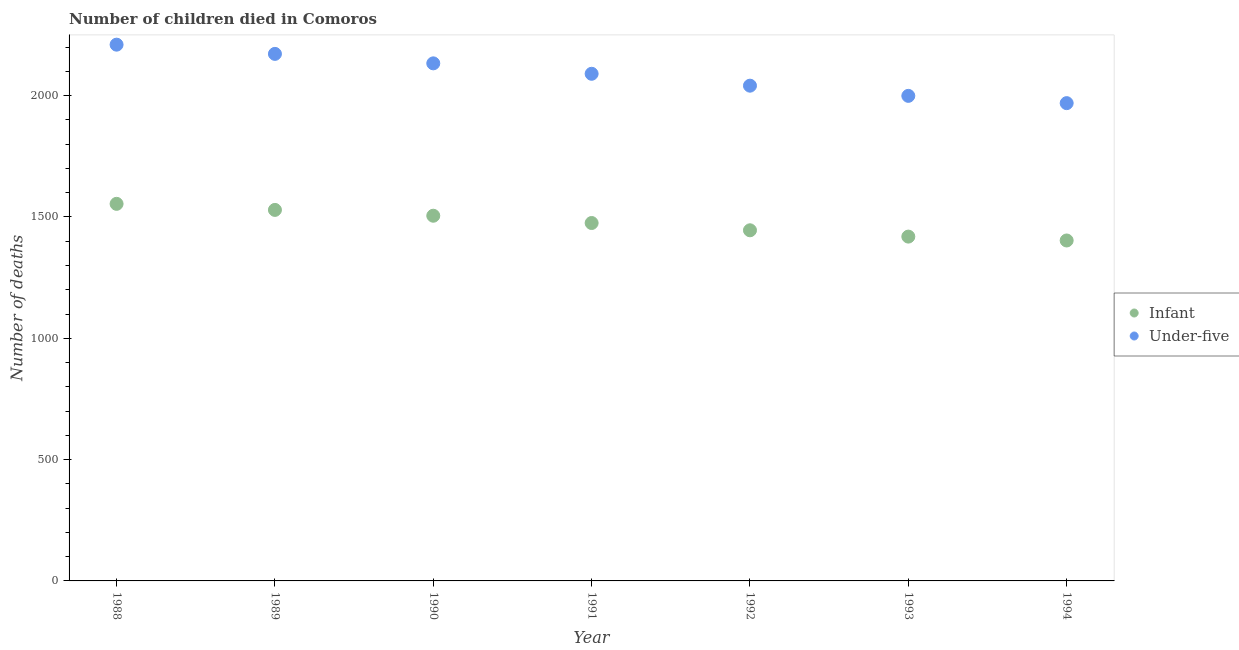Is the number of dotlines equal to the number of legend labels?
Your answer should be compact. Yes. What is the number of under-five deaths in 1994?
Give a very brief answer. 1969. Across all years, what is the maximum number of under-five deaths?
Offer a terse response. 2210. Across all years, what is the minimum number of under-five deaths?
Provide a succinct answer. 1969. In which year was the number of under-five deaths maximum?
Provide a succinct answer. 1988. In which year was the number of under-five deaths minimum?
Make the answer very short. 1994. What is the total number of under-five deaths in the graph?
Your answer should be compact. 1.46e+04. What is the difference between the number of infant deaths in 1988 and that in 1994?
Provide a short and direct response. 151. What is the difference between the number of under-five deaths in 1990 and the number of infant deaths in 1992?
Ensure brevity in your answer.  688. What is the average number of infant deaths per year?
Your response must be concise. 1475.71. In the year 1991, what is the difference between the number of under-five deaths and number of infant deaths?
Your response must be concise. 615. What is the ratio of the number of under-five deaths in 1989 to that in 1990?
Provide a succinct answer. 1.02. What is the difference between the highest and the second highest number of infant deaths?
Ensure brevity in your answer.  25. What is the difference between the highest and the lowest number of infant deaths?
Your answer should be very brief. 151. Is the sum of the number of under-five deaths in 1989 and 1994 greater than the maximum number of infant deaths across all years?
Keep it short and to the point. Yes. Is the number of infant deaths strictly greater than the number of under-five deaths over the years?
Offer a terse response. No. How many dotlines are there?
Ensure brevity in your answer.  2. Does the graph contain grids?
Offer a very short reply. No. How many legend labels are there?
Provide a short and direct response. 2. What is the title of the graph?
Provide a succinct answer. Number of children died in Comoros. Does "Depositors" appear as one of the legend labels in the graph?
Your answer should be very brief. No. What is the label or title of the X-axis?
Ensure brevity in your answer.  Year. What is the label or title of the Y-axis?
Make the answer very short. Number of deaths. What is the Number of deaths in Infant in 1988?
Provide a short and direct response. 1554. What is the Number of deaths in Under-five in 1988?
Provide a succinct answer. 2210. What is the Number of deaths in Infant in 1989?
Keep it short and to the point. 1529. What is the Number of deaths of Under-five in 1989?
Provide a succinct answer. 2172. What is the Number of deaths in Infant in 1990?
Your answer should be compact. 1505. What is the Number of deaths of Under-five in 1990?
Provide a succinct answer. 2133. What is the Number of deaths of Infant in 1991?
Your answer should be compact. 1475. What is the Number of deaths of Under-five in 1991?
Make the answer very short. 2090. What is the Number of deaths in Infant in 1992?
Keep it short and to the point. 1445. What is the Number of deaths in Under-five in 1992?
Give a very brief answer. 2041. What is the Number of deaths in Infant in 1993?
Keep it short and to the point. 1419. What is the Number of deaths of Under-five in 1993?
Your answer should be compact. 1999. What is the Number of deaths in Infant in 1994?
Provide a short and direct response. 1403. What is the Number of deaths of Under-five in 1994?
Your response must be concise. 1969. Across all years, what is the maximum Number of deaths of Infant?
Make the answer very short. 1554. Across all years, what is the maximum Number of deaths in Under-five?
Your response must be concise. 2210. Across all years, what is the minimum Number of deaths of Infant?
Offer a very short reply. 1403. Across all years, what is the minimum Number of deaths of Under-five?
Offer a terse response. 1969. What is the total Number of deaths of Infant in the graph?
Give a very brief answer. 1.03e+04. What is the total Number of deaths of Under-five in the graph?
Your response must be concise. 1.46e+04. What is the difference between the Number of deaths of Infant in 1988 and that in 1989?
Keep it short and to the point. 25. What is the difference between the Number of deaths in Infant in 1988 and that in 1990?
Ensure brevity in your answer.  49. What is the difference between the Number of deaths of Infant in 1988 and that in 1991?
Make the answer very short. 79. What is the difference between the Number of deaths of Under-five in 1988 and that in 1991?
Your response must be concise. 120. What is the difference between the Number of deaths of Infant in 1988 and that in 1992?
Offer a terse response. 109. What is the difference between the Number of deaths in Under-five in 1988 and that in 1992?
Offer a very short reply. 169. What is the difference between the Number of deaths of Infant in 1988 and that in 1993?
Make the answer very short. 135. What is the difference between the Number of deaths in Under-five in 1988 and that in 1993?
Your answer should be compact. 211. What is the difference between the Number of deaths of Infant in 1988 and that in 1994?
Make the answer very short. 151. What is the difference between the Number of deaths in Under-five in 1988 and that in 1994?
Give a very brief answer. 241. What is the difference between the Number of deaths in Under-five in 1989 and that in 1991?
Give a very brief answer. 82. What is the difference between the Number of deaths of Infant in 1989 and that in 1992?
Make the answer very short. 84. What is the difference between the Number of deaths of Under-five in 1989 and that in 1992?
Provide a succinct answer. 131. What is the difference between the Number of deaths of Infant in 1989 and that in 1993?
Your response must be concise. 110. What is the difference between the Number of deaths of Under-five in 1989 and that in 1993?
Your answer should be very brief. 173. What is the difference between the Number of deaths of Infant in 1989 and that in 1994?
Offer a very short reply. 126. What is the difference between the Number of deaths in Under-five in 1989 and that in 1994?
Offer a terse response. 203. What is the difference between the Number of deaths in Infant in 1990 and that in 1991?
Offer a very short reply. 30. What is the difference between the Number of deaths in Infant in 1990 and that in 1992?
Offer a very short reply. 60. What is the difference between the Number of deaths of Under-five in 1990 and that in 1992?
Ensure brevity in your answer.  92. What is the difference between the Number of deaths in Under-five in 1990 and that in 1993?
Your answer should be compact. 134. What is the difference between the Number of deaths of Infant in 1990 and that in 1994?
Make the answer very short. 102. What is the difference between the Number of deaths of Under-five in 1990 and that in 1994?
Make the answer very short. 164. What is the difference between the Number of deaths of Infant in 1991 and that in 1992?
Your response must be concise. 30. What is the difference between the Number of deaths in Under-five in 1991 and that in 1993?
Offer a terse response. 91. What is the difference between the Number of deaths in Infant in 1991 and that in 1994?
Keep it short and to the point. 72. What is the difference between the Number of deaths of Under-five in 1991 and that in 1994?
Make the answer very short. 121. What is the difference between the Number of deaths in Infant in 1992 and that in 1993?
Offer a very short reply. 26. What is the difference between the Number of deaths of Infant in 1992 and that in 1994?
Your answer should be compact. 42. What is the difference between the Number of deaths of Under-five in 1992 and that in 1994?
Your answer should be very brief. 72. What is the difference between the Number of deaths of Under-five in 1993 and that in 1994?
Your answer should be very brief. 30. What is the difference between the Number of deaths of Infant in 1988 and the Number of deaths of Under-five in 1989?
Give a very brief answer. -618. What is the difference between the Number of deaths of Infant in 1988 and the Number of deaths of Under-five in 1990?
Provide a short and direct response. -579. What is the difference between the Number of deaths of Infant in 1988 and the Number of deaths of Under-five in 1991?
Your answer should be compact. -536. What is the difference between the Number of deaths of Infant in 1988 and the Number of deaths of Under-five in 1992?
Provide a succinct answer. -487. What is the difference between the Number of deaths in Infant in 1988 and the Number of deaths in Under-five in 1993?
Give a very brief answer. -445. What is the difference between the Number of deaths in Infant in 1988 and the Number of deaths in Under-five in 1994?
Provide a short and direct response. -415. What is the difference between the Number of deaths in Infant in 1989 and the Number of deaths in Under-five in 1990?
Keep it short and to the point. -604. What is the difference between the Number of deaths in Infant in 1989 and the Number of deaths in Under-five in 1991?
Keep it short and to the point. -561. What is the difference between the Number of deaths in Infant in 1989 and the Number of deaths in Under-five in 1992?
Give a very brief answer. -512. What is the difference between the Number of deaths of Infant in 1989 and the Number of deaths of Under-five in 1993?
Your answer should be compact. -470. What is the difference between the Number of deaths in Infant in 1989 and the Number of deaths in Under-five in 1994?
Your response must be concise. -440. What is the difference between the Number of deaths in Infant in 1990 and the Number of deaths in Under-five in 1991?
Give a very brief answer. -585. What is the difference between the Number of deaths of Infant in 1990 and the Number of deaths of Under-five in 1992?
Your response must be concise. -536. What is the difference between the Number of deaths in Infant in 1990 and the Number of deaths in Under-five in 1993?
Your response must be concise. -494. What is the difference between the Number of deaths in Infant in 1990 and the Number of deaths in Under-five in 1994?
Give a very brief answer. -464. What is the difference between the Number of deaths of Infant in 1991 and the Number of deaths of Under-five in 1992?
Provide a short and direct response. -566. What is the difference between the Number of deaths in Infant in 1991 and the Number of deaths in Under-five in 1993?
Ensure brevity in your answer.  -524. What is the difference between the Number of deaths of Infant in 1991 and the Number of deaths of Under-five in 1994?
Your answer should be compact. -494. What is the difference between the Number of deaths in Infant in 1992 and the Number of deaths in Under-five in 1993?
Your response must be concise. -554. What is the difference between the Number of deaths in Infant in 1992 and the Number of deaths in Under-five in 1994?
Your response must be concise. -524. What is the difference between the Number of deaths in Infant in 1993 and the Number of deaths in Under-five in 1994?
Give a very brief answer. -550. What is the average Number of deaths of Infant per year?
Your response must be concise. 1475.71. What is the average Number of deaths of Under-five per year?
Offer a very short reply. 2087.71. In the year 1988, what is the difference between the Number of deaths of Infant and Number of deaths of Under-five?
Your response must be concise. -656. In the year 1989, what is the difference between the Number of deaths in Infant and Number of deaths in Under-five?
Give a very brief answer. -643. In the year 1990, what is the difference between the Number of deaths in Infant and Number of deaths in Under-five?
Your answer should be compact. -628. In the year 1991, what is the difference between the Number of deaths in Infant and Number of deaths in Under-five?
Provide a short and direct response. -615. In the year 1992, what is the difference between the Number of deaths of Infant and Number of deaths of Under-five?
Give a very brief answer. -596. In the year 1993, what is the difference between the Number of deaths in Infant and Number of deaths in Under-five?
Make the answer very short. -580. In the year 1994, what is the difference between the Number of deaths of Infant and Number of deaths of Under-five?
Make the answer very short. -566. What is the ratio of the Number of deaths of Infant in 1988 to that in 1989?
Offer a very short reply. 1.02. What is the ratio of the Number of deaths of Under-five in 1988 to that in 1989?
Ensure brevity in your answer.  1.02. What is the ratio of the Number of deaths of Infant in 1988 to that in 1990?
Provide a short and direct response. 1.03. What is the ratio of the Number of deaths in Under-five in 1988 to that in 1990?
Your answer should be very brief. 1.04. What is the ratio of the Number of deaths in Infant in 1988 to that in 1991?
Your answer should be compact. 1.05. What is the ratio of the Number of deaths of Under-five in 1988 to that in 1991?
Offer a very short reply. 1.06. What is the ratio of the Number of deaths in Infant in 1988 to that in 1992?
Your response must be concise. 1.08. What is the ratio of the Number of deaths of Under-five in 1988 to that in 1992?
Offer a terse response. 1.08. What is the ratio of the Number of deaths in Infant in 1988 to that in 1993?
Keep it short and to the point. 1.1. What is the ratio of the Number of deaths in Under-five in 1988 to that in 1993?
Your answer should be compact. 1.11. What is the ratio of the Number of deaths in Infant in 1988 to that in 1994?
Your answer should be compact. 1.11. What is the ratio of the Number of deaths in Under-five in 1988 to that in 1994?
Offer a terse response. 1.12. What is the ratio of the Number of deaths in Infant in 1989 to that in 1990?
Your answer should be compact. 1.02. What is the ratio of the Number of deaths in Under-five in 1989 to that in 1990?
Offer a terse response. 1.02. What is the ratio of the Number of deaths in Infant in 1989 to that in 1991?
Make the answer very short. 1.04. What is the ratio of the Number of deaths of Under-five in 1989 to that in 1991?
Your answer should be very brief. 1.04. What is the ratio of the Number of deaths of Infant in 1989 to that in 1992?
Your answer should be very brief. 1.06. What is the ratio of the Number of deaths in Under-five in 1989 to that in 1992?
Offer a very short reply. 1.06. What is the ratio of the Number of deaths of Infant in 1989 to that in 1993?
Offer a terse response. 1.08. What is the ratio of the Number of deaths in Under-five in 1989 to that in 1993?
Provide a succinct answer. 1.09. What is the ratio of the Number of deaths in Infant in 1989 to that in 1994?
Offer a very short reply. 1.09. What is the ratio of the Number of deaths of Under-five in 1989 to that in 1994?
Keep it short and to the point. 1.1. What is the ratio of the Number of deaths of Infant in 1990 to that in 1991?
Your answer should be very brief. 1.02. What is the ratio of the Number of deaths in Under-five in 1990 to that in 1991?
Make the answer very short. 1.02. What is the ratio of the Number of deaths of Infant in 1990 to that in 1992?
Ensure brevity in your answer.  1.04. What is the ratio of the Number of deaths of Under-five in 1990 to that in 1992?
Your answer should be very brief. 1.05. What is the ratio of the Number of deaths of Infant in 1990 to that in 1993?
Provide a succinct answer. 1.06. What is the ratio of the Number of deaths of Under-five in 1990 to that in 1993?
Your answer should be very brief. 1.07. What is the ratio of the Number of deaths of Infant in 1990 to that in 1994?
Offer a terse response. 1.07. What is the ratio of the Number of deaths in Under-five in 1990 to that in 1994?
Give a very brief answer. 1.08. What is the ratio of the Number of deaths in Infant in 1991 to that in 1992?
Your answer should be very brief. 1.02. What is the ratio of the Number of deaths of Infant in 1991 to that in 1993?
Offer a very short reply. 1.04. What is the ratio of the Number of deaths in Under-five in 1991 to that in 1993?
Your answer should be compact. 1.05. What is the ratio of the Number of deaths in Infant in 1991 to that in 1994?
Make the answer very short. 1.05. What is the ratio of the Number of deaths in Under-five in 1991 to that in 1994?
Make the answer very short. 1.06. What is the ratio of the Number of deaths of Infant in 1992 to that in 1993?
Offer a terse response. 1.02. What is the ratio of the Number of deaths of Under-five in 1992 to that in 1993?
Provide a short and direct response. 1.02. What is the ratio of the Number of deaths in Infant in 1992 to that in 1994?
Provide a short and direct response. 1.03. What is the ratio of the Number of deaths of Under-five in 1992 to that in 1994?
Offer a very short reply. 1.04. What is the ratio of the Number of deaths in Infant in 1993 to that in 1994?
Your response must be concise. 1.01. What is the ratio of the Number of deaths in Under-five in 1993 to that in 1994?
Give a very brief answer. 1.02. What is the difference between the highest and the second highest Number of deaths in Infant?
Provide a short and direct response. 25. What is the difference between the highest and the lowest Number of deaths in Infant?
Your answer should be very brief. 151. What is the difference between the highest and the lowest Number of deaths of Under-five?
Make the answer very short. 241. 